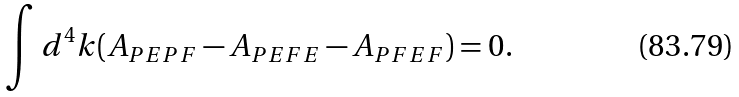<formula> <loc_0><loc_0><loc_500><loc_500>\int d ^ { 4 } k ( A _ { P E P F } - A _ { P E F E } - A _ { P F E F } ) = 0 .</formula> 